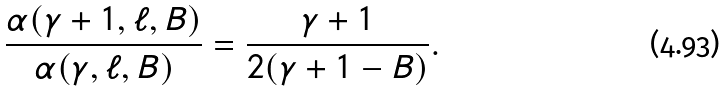Convert formula to latex. <formula><loc_0><loc_0><loc_500><loc_500>\frac { \alpha ( \gamma + 1 , \ell , B ) } { \alpha ( \gamma , \ell , B ) } = \frac { \gamma + 1 } { 2 ( \gamma + 1 - B ) } .</formula> 